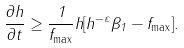<formula> <loc_0><loc_0><loc_500><loc_500>\frac { \partial h } { \partial t } \geq \frac { 1 } { f _ { \max } } h [ h ^ { - \varepsilon } \beta _ { 1 } - f _ { \max } ] .</formula> 